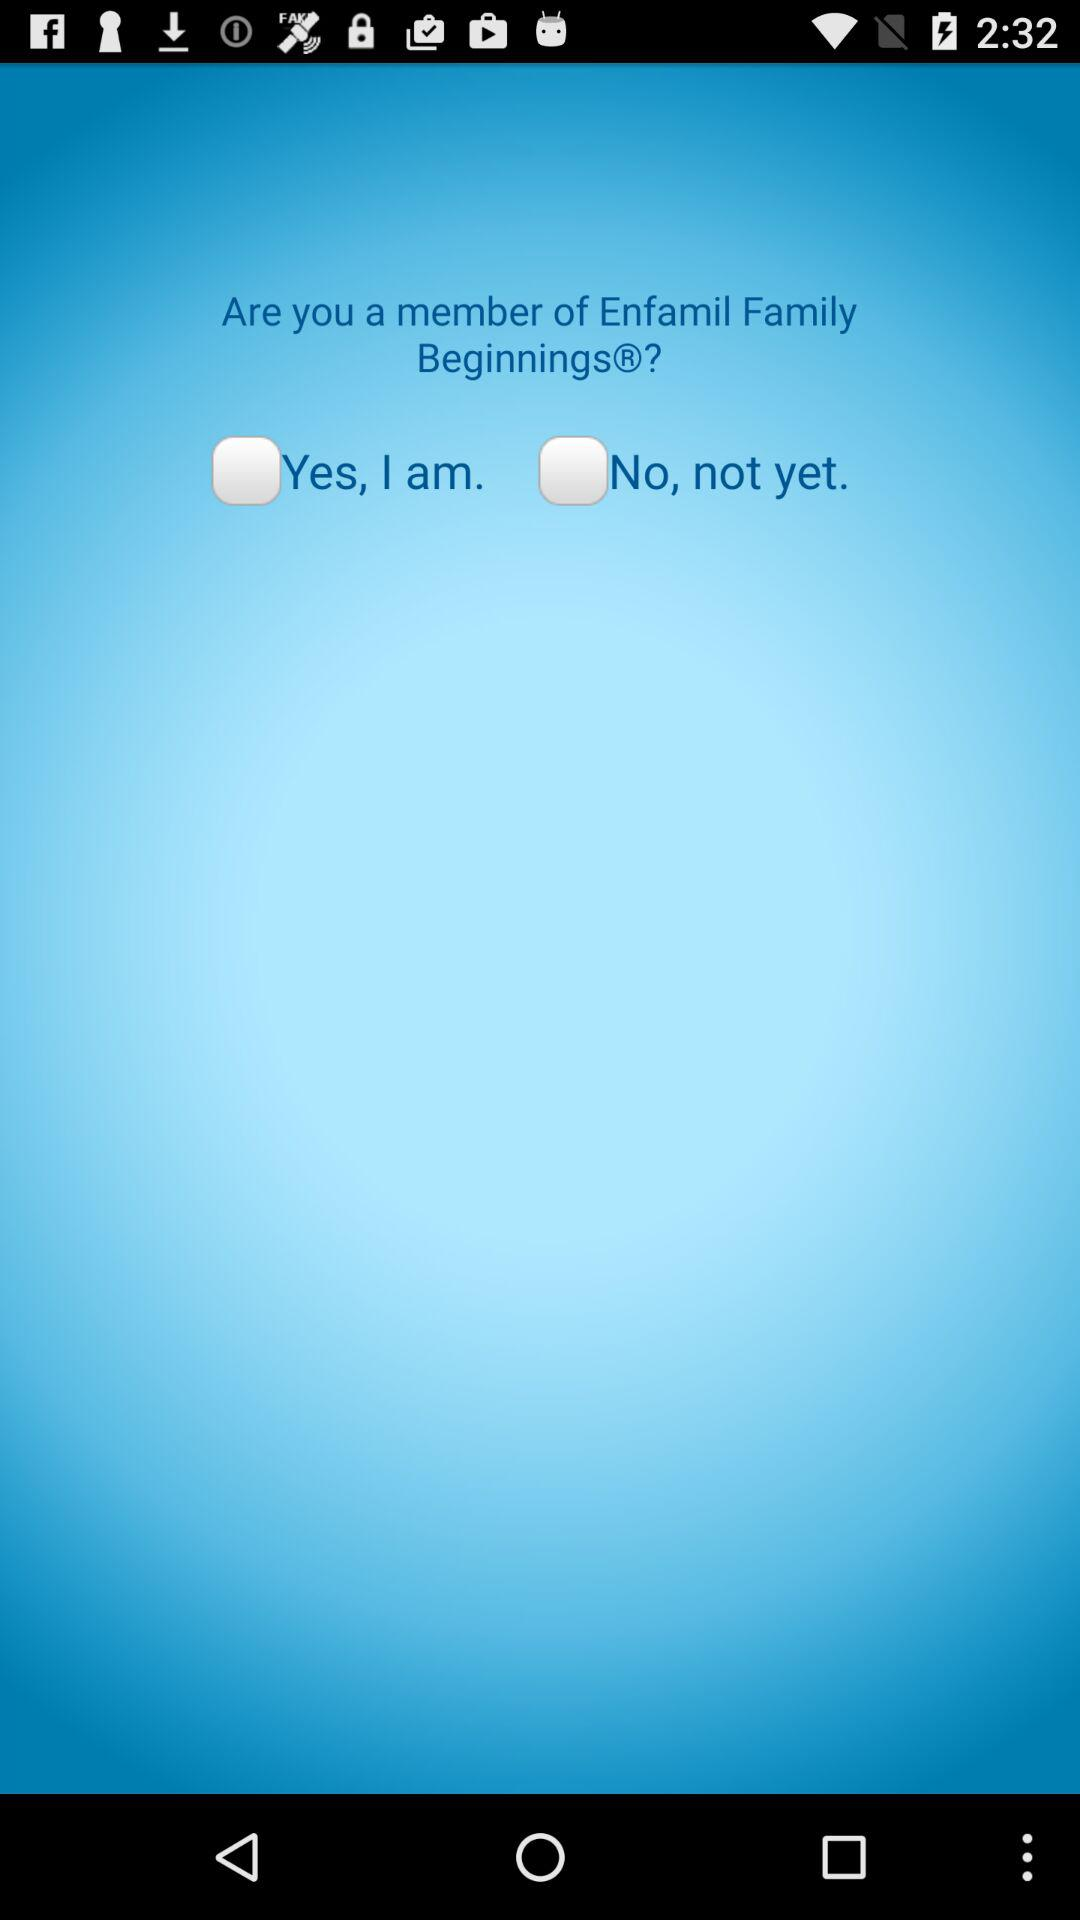What is the current status of "No, not yet."? The current status is "off". 